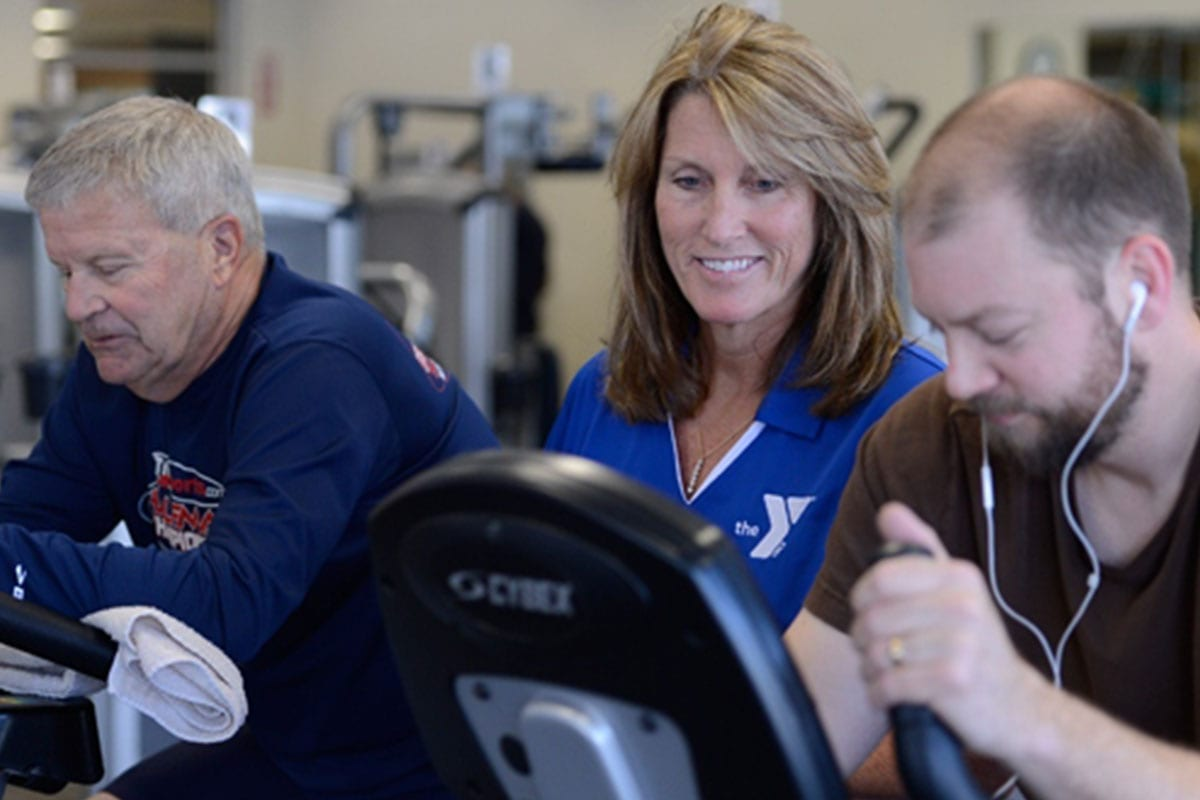Considering the focused expressions of the individuals using the exercise equipment and the presence of the instructor, what might be the purpose of the instructor's presence in this particular setting, and how does it contribute to the individuals' fitness experience? The instructor's presence in this setting serves multiple essential purposes. She provides expert guidance on the correct usage of exercise equipment, ensuring that the individuals maintain proper form and technique to maximize the effectiveness of their workouts and to prevent injuries. The instructor also offers personalized advice and adjusts the exercise routines according to each individual's fitness level and goals. Additionally, her role includes motivating the participants, a factor that can significantly enhance the engagement and enjoyment of their fitness experience. Her attentive and encouraging demeanor likely contributes to a positive and supportive environment, making the workout session more productive and enjoyable for the individuals involved. 